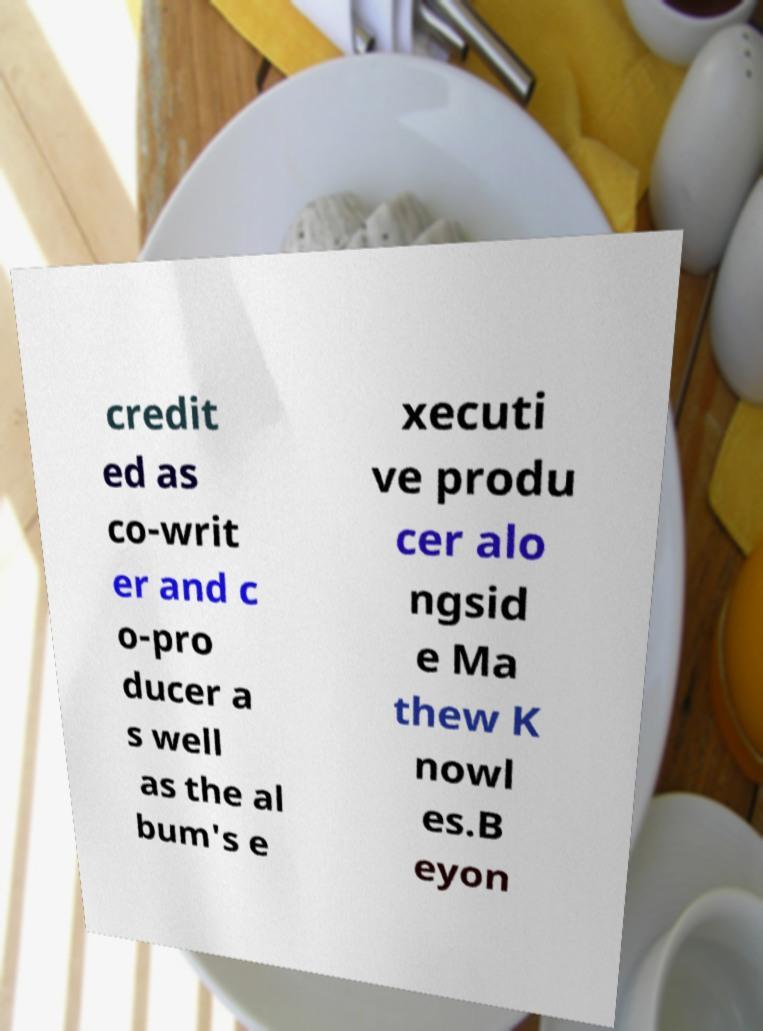Please identify and transcribe the text found in this image. credit ed as co-writ er and c o-pro ducer a s well as the al bum's e xecuti ve produ cer alo ngsid e Ma thew K nowl es.B eyon 